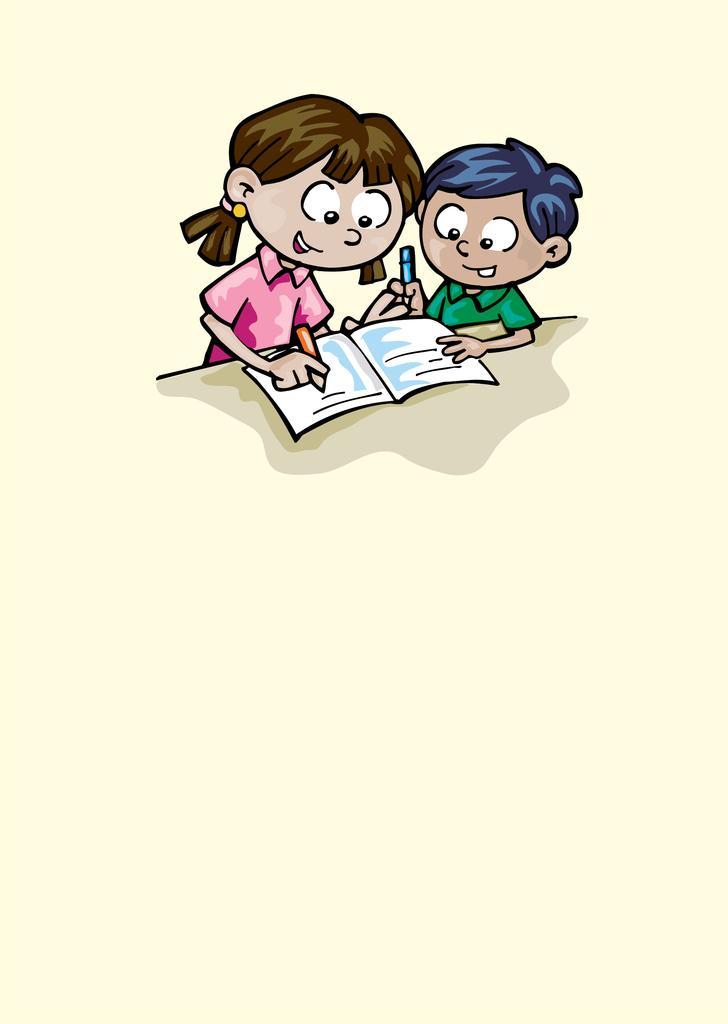How would you summarize this image in a sentence or two? This is a cartoon image, we can see a boy and a girl, boy is holding a pencil and looking at the book and girl is holding a pencil and writing something in the book. 